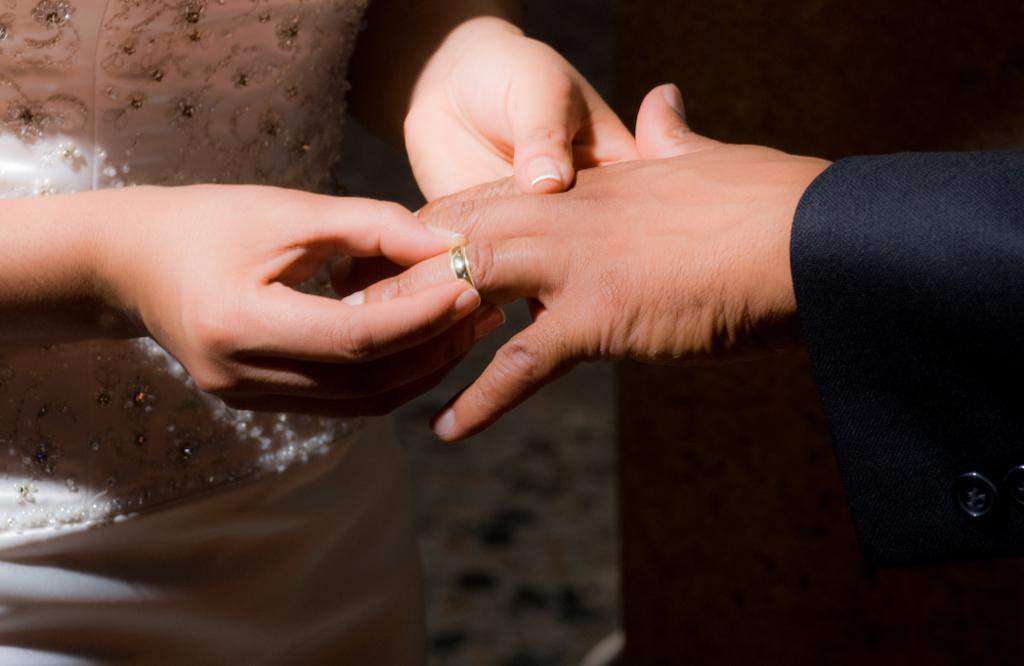What is the main subject of the image? The main subject of the image is a woman. What is the woman doing in the image? The woman is holding a man's hand and showing a ring. Can you see a giraffe in the image? No, there is no giraffe present in the image. What type of cloud is visible in the image? There is no cloud visible in the image. What type of trade is being conducted in the image? There is no trade being conducted in the image; it features a woman holding a man's hand and showing a ring. 